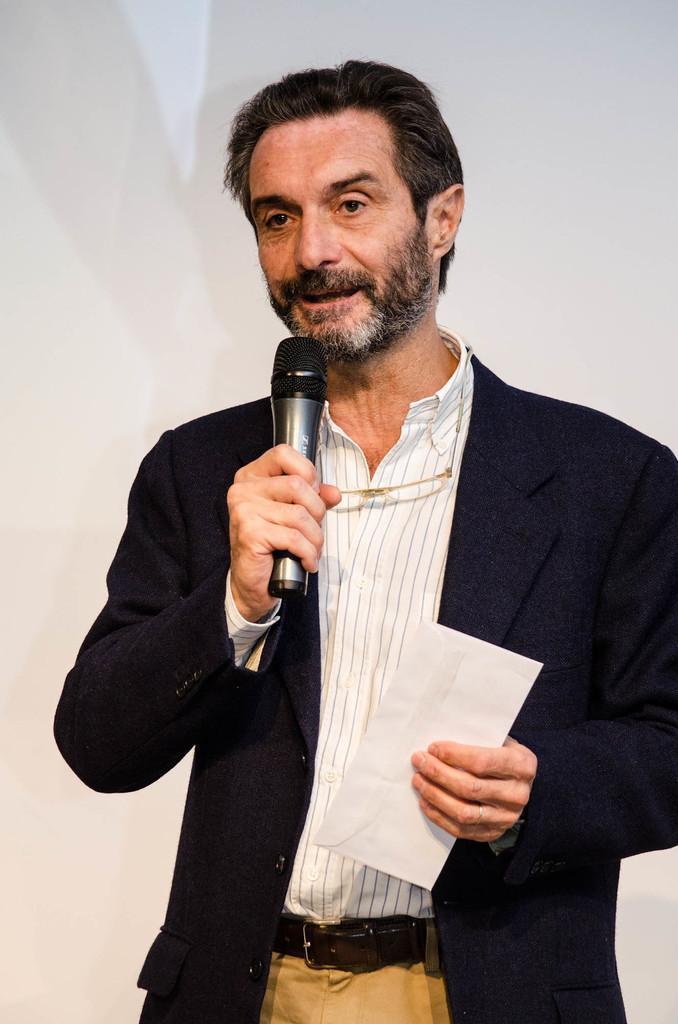Can you describe this image briefly? There is a person standing in the center. He is wearing a suit and he is speaking on a microphone. 